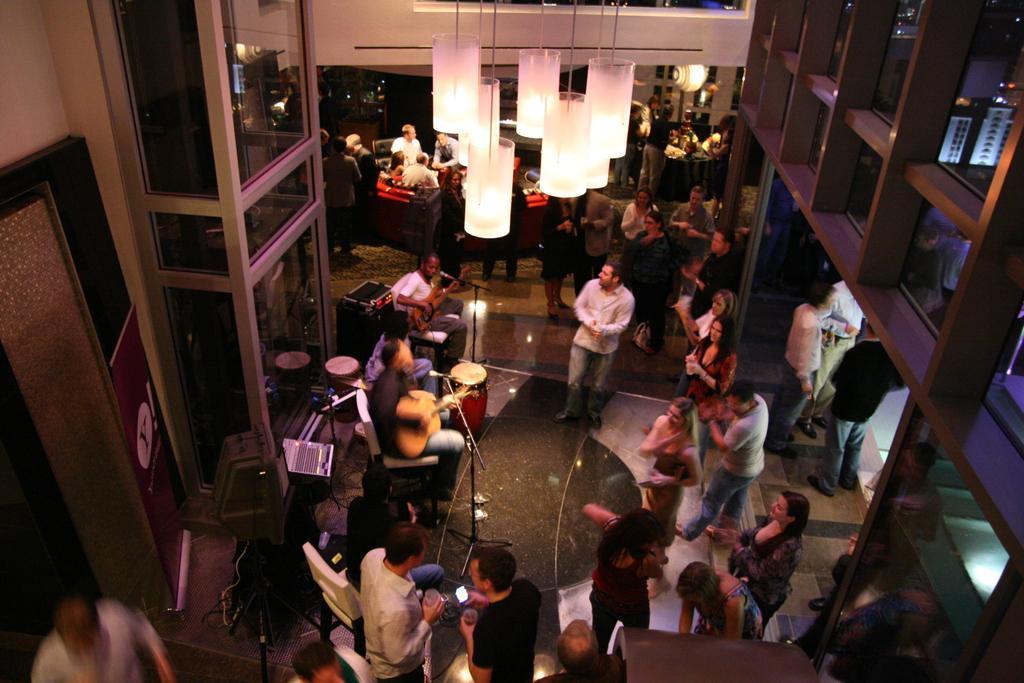Can you describe this image briefly? The picture is taken in a restaurant or in a party. In the center of the picture there is a musical band and there are many people standing. In the background there are couches, lights and people. On the right there are windows, outside the windows there are buildings. On the left there is a door and a glass wall. 